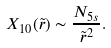Convert formula to latex. <formula><loc_0><loc_0><loc_500><loc_500>X _ { 1 0 } ( \tilde { r } ) \sim \frac { N _ { 5 s } } { \tilde { r } ^ { 2 } } .</formula> 